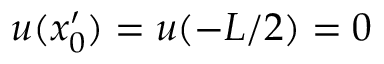Convert formula to latex. <formula><loc_0><loc_0><loc_500><loc_500>u ( x _ { 0 } ^ { \prime } ) = u ( - L / 2 ) = 0</formula> 